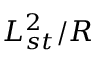<formula> <loc_0><loc_0><loc_500><loc_500>L _ { s t } ^ { 2 } / R</formula> 